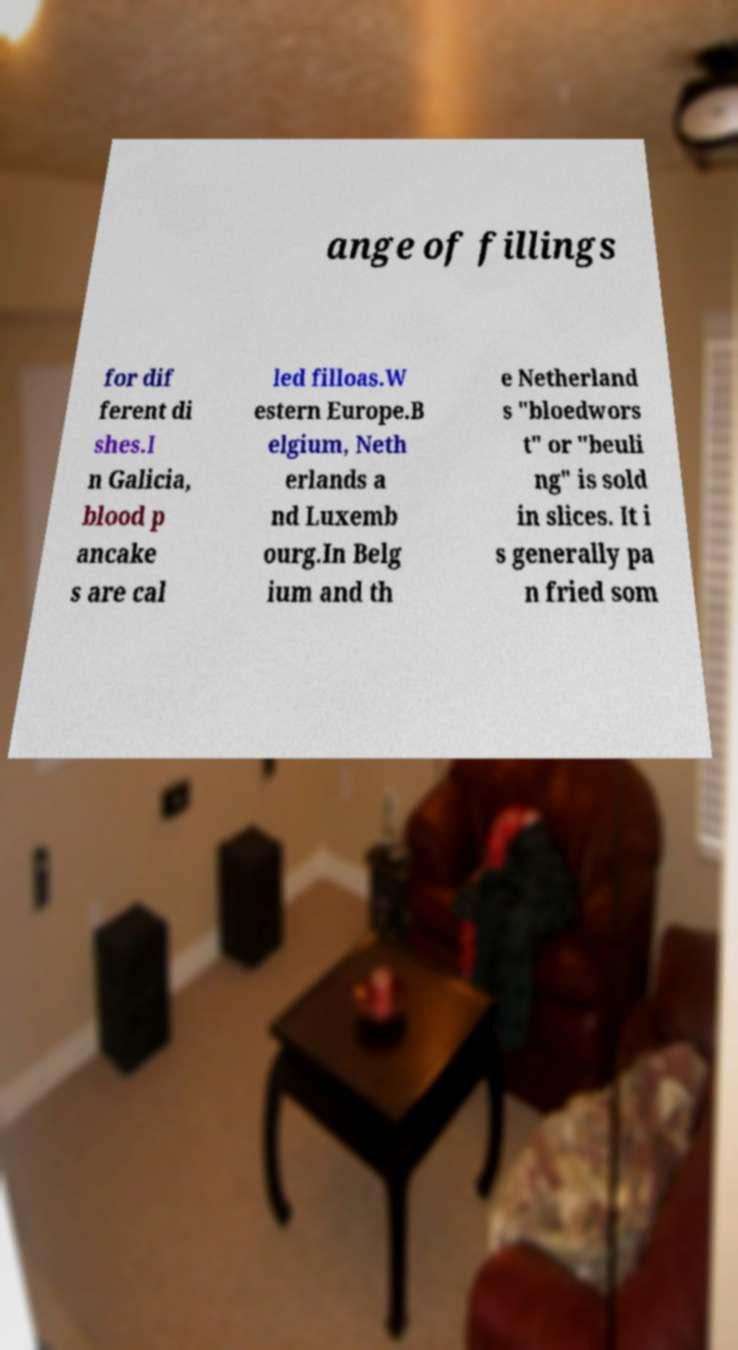I need the written content from this picture converted into text. Can you do that? ange of fillings for dif ferent di shes.I n Galicia, blood p ancake s are cal led filloas.W estern Europe.B elgium, Neth erlands a nd Luxemb ourg.In Belg ium and th e Netherland s "bloedwors t" or "beuli ng" is sold in slices. It i s generally pa n fried som 